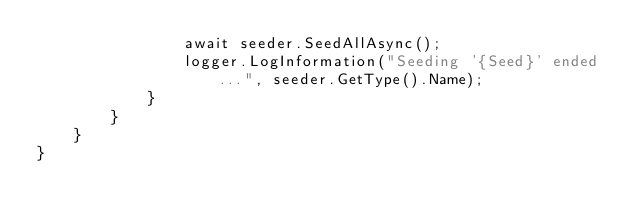Convert code to text. <code><loc_0><loc_0><loc_500><loc_500><_C#_>                await seeder.SeedAllAsync();
                logger.LogInformation("Seeding '{Seed}' ended...", seeder.GetType().Name);
            }
        }
    }
}</code> 